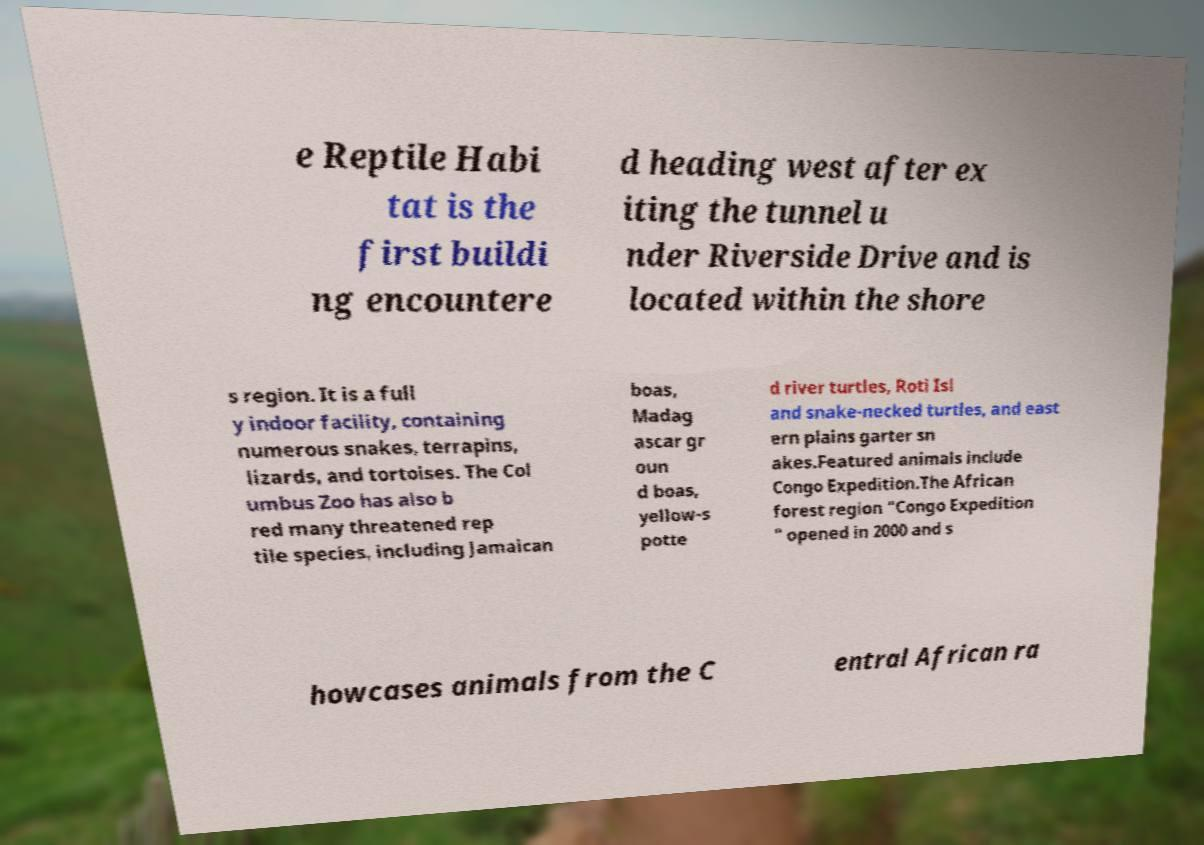There's text embedded in this image that I need extracted. Can you transcribe it verbatim? e Reptile Habi tat is the first buildi ng encountere d heading west after ex iting the tunnel u nder Riverside Drive and is located within the shore s region. It is a full y indoor facility, containing numerous snakes, terrapins, lizards, and tortoises. The Col umbus Zoo has also b red many threatened rep tile species, including Jamaican boas, Madag ascar gr oun d boas, yellow-s potte d river turtles, Roti Isl and snake-necked turtles, and east ern plains garter sn akes.Featured animals include Congo Expedition.The African forest region "Congo Expedition " opened in 2000 and s howcases animals from the C entral African ra 